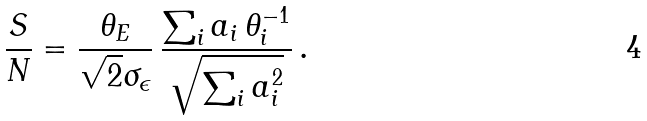<formula> <loc_0><loc_0><loc_500><loc_500>\frac { S } { N } = \frac { \theta _ { E } } { \sqrt { 2 } \sigma _ { \epsilon } } \, \frac { \sum _ { i } a _ { i } \, \theta _ { i } ^ { - 1 } } { \sqrt { \sum _ { i } a _ { i } ^ { 2 } } } \, .</formula> 